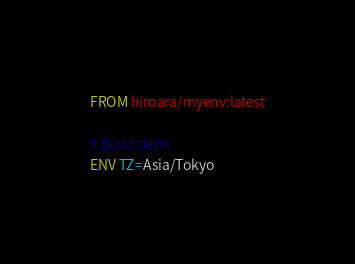Convert code to text. <code><loc_0><loc_0><loc_500><loc_500><_Dockerfile_>FROM hiroara/myenv:latest

# Build deps
ENV TZ=Asia/Tokyo</code> 